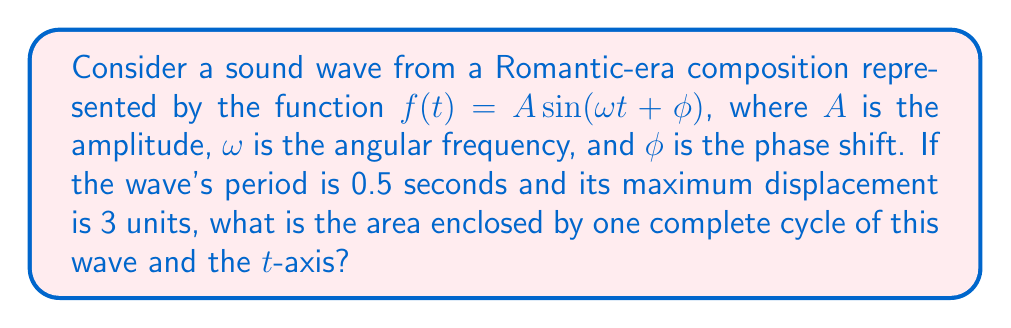What is the answer to this math problem? Let's approach this step-by-step:

1) First, we need to determine the angular frequency $\omega$:
   The period $T$ is given as 0.5 seconds.
   We know that $\omega = \frac{2\pi}{T}$
   So, $\omega = \frac{2\pi}{0.5} = 4\pi$ rad/s

2) The amplitude $A$ is given as 3 units.

3) The general equation of the wave is:
   $f(t) = 3 \sin(4\pi t + \phi)$

4) To find the area, we need to integrate the absolute value of this function over one complete period:

   $$\text{Area} = \int_0^{0.5} |3 \sin(4\pi t + \phi)| dt$$

5) The phase shift $\phi$ doesn't affect the area, so we can ignore it:

   $$\text{Area} = \int_0^{0.5} |3 \sin(4\pi t)| dt$$

6) This integral can be solved using the formula:
   $$\int_0^T |\sin(\omega t)| dt = \frac{4}{\omega}$$

7) Applying this to our problem:
   $$\text{Area} = 3 \cdot \frac{4}{4\pi} = \frac{3}{\pi}$$

8) Therefore, the area enclosed by one complete cycle of the wave and the t-axis is $\frac{3}{\pi}$ square units.
Answer: $\frac{3}{\pi}$ square units 